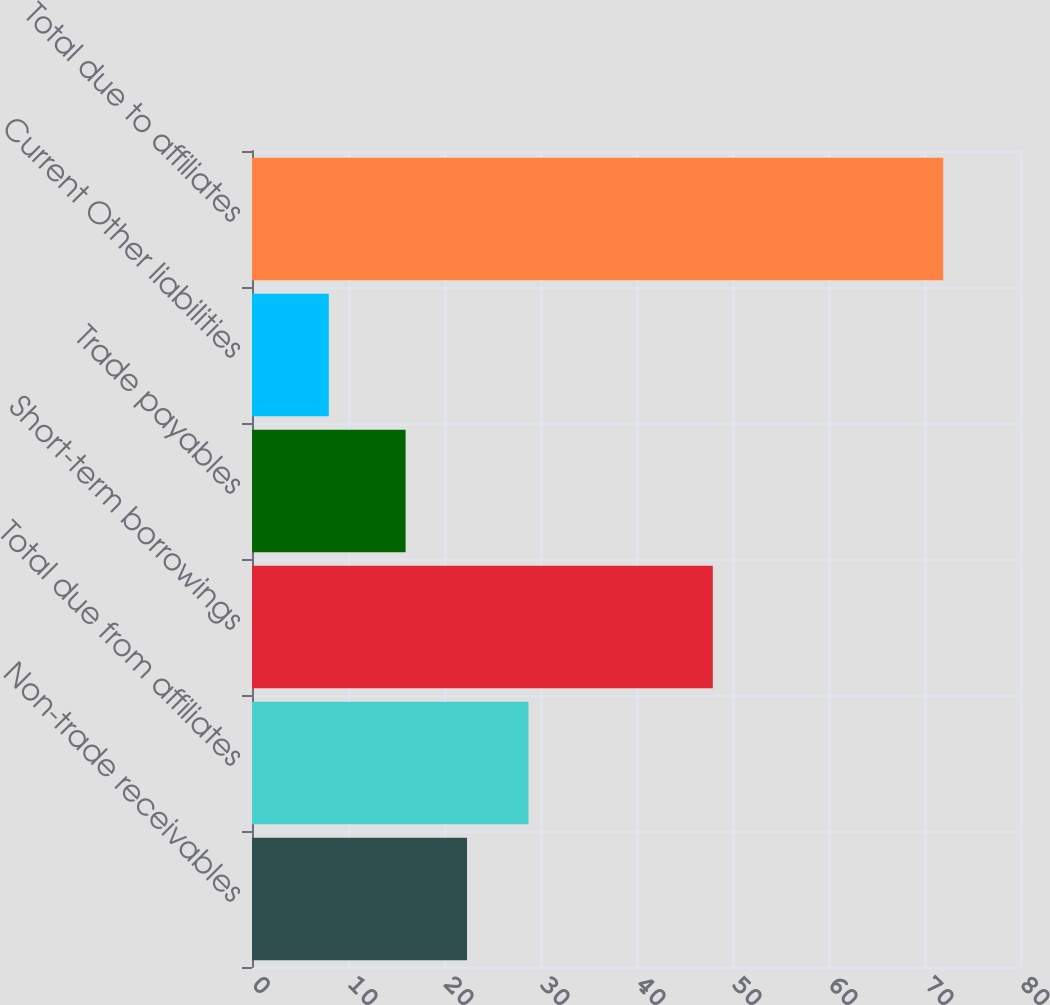<chart> <loc_0><loc_0><loc_500><loc_500><bar_chart><fcel>Non-trade receivables<fcel>Total due from affiliates<fcel>Short-term borrowings<fcel>Trade payables<fcel>Current Other liabilities<fcel>Total due to affiliates<nl><fcel>22.4<fcel>28.8<fcel>48<fcel>16<fcel>8<fcel>72<nl></chart> 